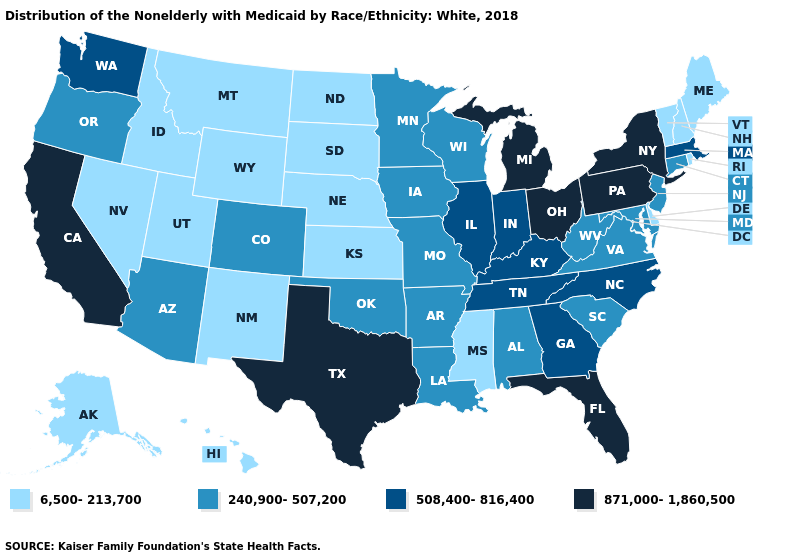Among the states that border Wyoming , which have the lowest value?
Short answer required. Idaho, Montana, Nebraska, South Dakota, Utah. Does California have the highest value in the West?
Be succinct. Yes. Does Kansas have the highest value in the MidWest?
Quick response, please. No. Does Utah have the lowest value in the West?
Keep it brief. Yes. How many symbols are there in the legend?
Write a very short answer. 4. Does Nebraska have the highest value in the USA?
Keep it brief. No. Among the states that border Arkansas , which have the lowest value?
Be succinct. Mississippi. Which states have the highest value in the USA?
Concise answer only. California, Florida, Michigan, New York, Ohio, Pennsylvania, Texas. What is the value of New Jersey?
Quick response, please. 240,900-507,200. What is the lowest value in the USA?
Give a very brief answer. 6,500-213,700. What is the lowest value in states that border Delaware?
Quick response, please. 240,900-507,200. Name the states that have a value in the range 508,400-816,400?
Write a very short answer. Georgia, Illinois, Indiana, Kentucky, Massachusetts, North Carolina, Tennessee, Washington. What is the highest value in the MidWest ?
Short answer required. 871,000-1,860,500. What is the value of Massachusetts?
Write a very short answer. 508,400-816,400. Among the states that border Maine , which have the highest value?
Answer briefly. New Hampshire. 